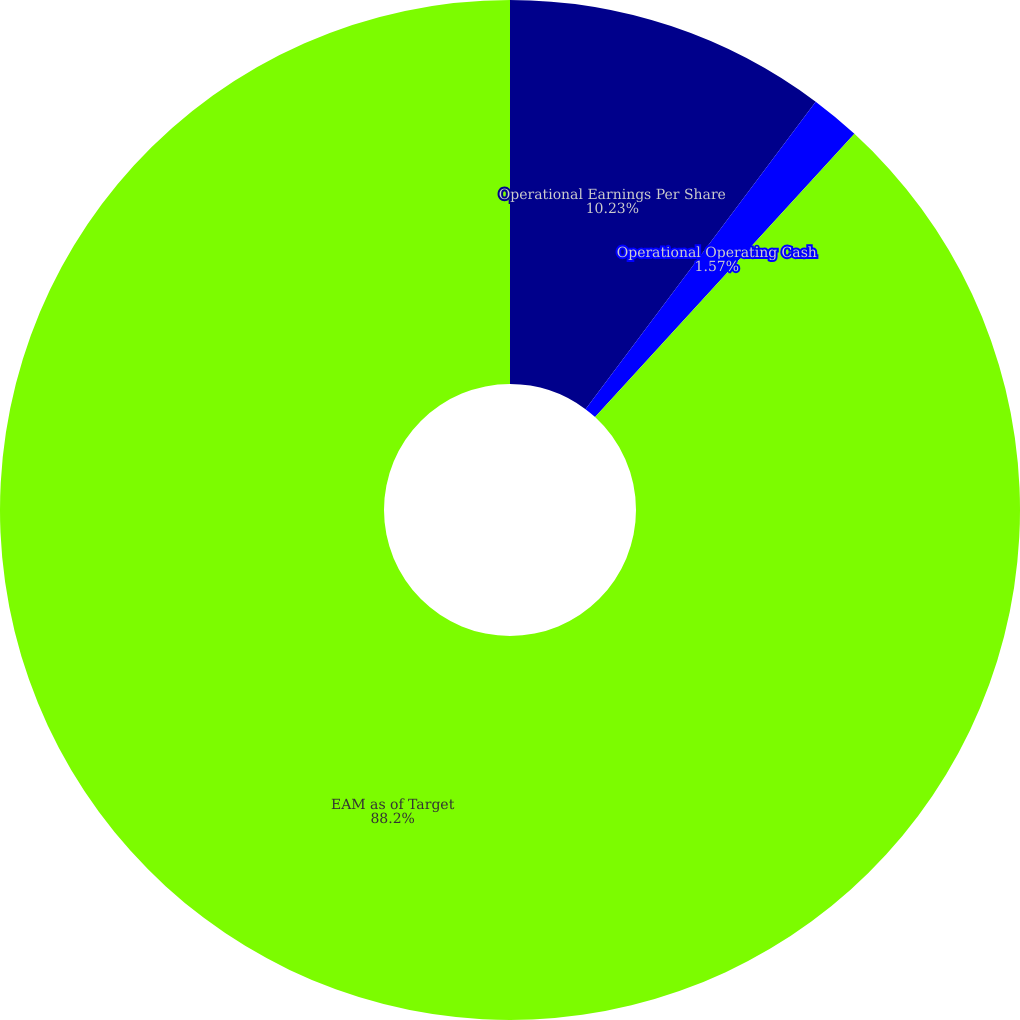Convert chart to OTSL. <chart><loc_0><loc_0><loc_500><loc_500><pie_chart><fcel>Operational Earnings Per Share<fcel>Operational Operating Cash<fcel>EAM as of Target<nl><fcel>10.23%<fcel>1.57%<fcel>88.2%<nl></chart> 